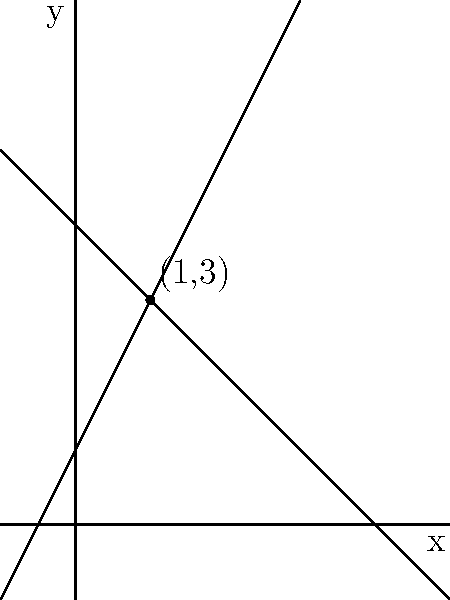Remember that old math classroom where we used to sit together, solving equations? Here's a problem that might jog your memory. The graph shows two lines representing a system of linear equations. What are the coordinates of the point where these lines intersect? Let's approach this step-by-step, just like we used to in class:

1) We can see from the graph that the two lines intersect at a point. This point of intersection is the solution to the system of linear equations represented by these lines.

2) By visual inspection, we can estimate that the point of intersection appears to be at (1, 3).

3) To verify this, we can:
   a) Find the equations of both lines
   b) Solve the system of equations algebraically

4) From the graph, we can determine:
   - The blue line has a positive slope and y-intercept of 1. Its equation is likely $y = 2x + 1$
   - The red line has a negative slope and y-intercept of 4. Its equation is likely $y = -x + 4$

5) Now we have the system of equations:
   $$\begin{cases}
   y = 2x + 1 \\
   y = -x + 4
   \end{cases}$$

6) To solve, we can equate these:
   $2x + 1 = -x + 4$

7) Solving for x:
   $3x = 3$
   $x = 1$

8) Substituting this back into either equation:
   $y = 2(1) + 1 = 3$ or $y = -1 + 4 = 3$

9) Therefore, the point of intersection is indeed (1, 3), confirming our visual estimate.
Answer: (1, 3) 